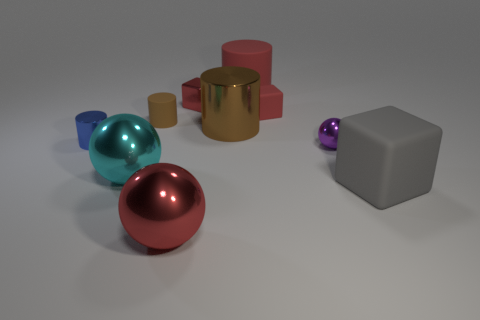What materials do the objects in the scene seem to be made from? The objects in the scene exhibit varying sheens and colors that suggest they might be made from different materials such as metal, for the shiny gold and red cubes, and possibly plastic or ceramic for the matte gray block and the smaller, more colorful shapes. 